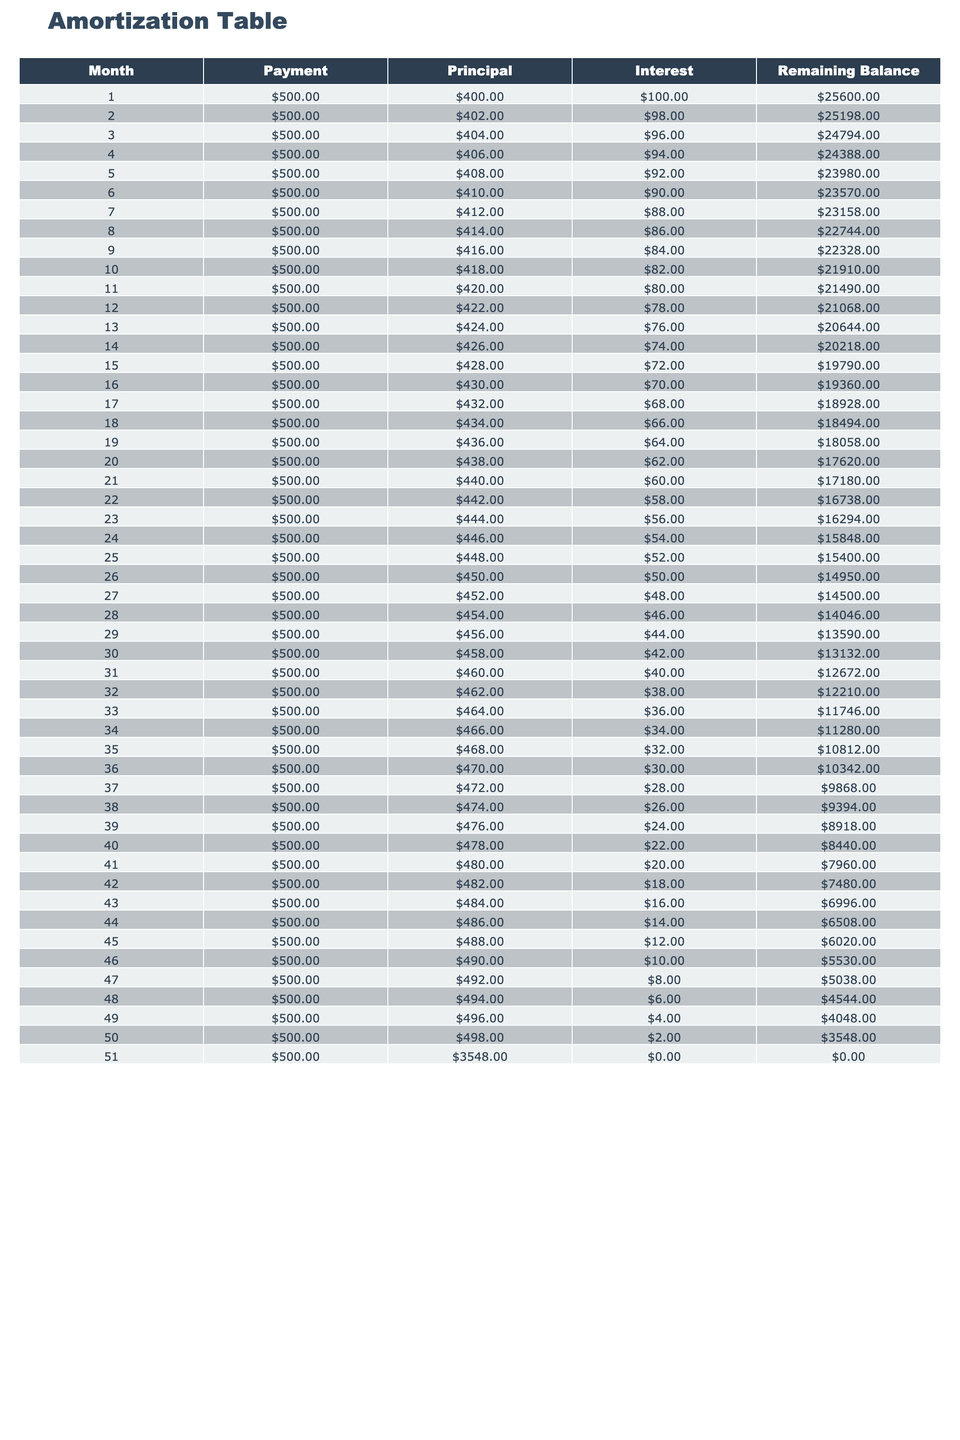What is the payment for the first month? The payment amount in the first row of the table under the "Payment" column shows 500.00.
Answer: 500.00 What is the remaining balance after the second month? In the second row of the table, the "Remaining Balance" column states 25198.00. Thus, after the second month, the remaining balance is 25198.00.
Answer: 25198.00 How much total principal is paid off in the first 5 months? The principal amounts in the first 5 months are 400.00, 402.00, 404.00, 406.00, and 408.00 respectively. Summing these values: 400 + 402 + 404 + 406 + 408 = 2020.00.
Answer: 2020.00 Is the interest payment in the last month equal to zero? In the last row for the 51st month, the "Interest" amount is 0.00, which confirms that the interest paid in this month is indeed zero.
Answer: Yes What is the average amount of interest paid over the first 12 months? The interest payments for the first 12 months are 100.00, 98.00, 96.00, 94.00, 92.00, 90.00, 88.00, 86.00, 84.00, 82.00, 80.00, and 78.00. Summing these values: 100 + 98 + 96 + 94 + 92 + 90 + 88 + 86 + 84 + 82 + 80 + 78 = 1092.00. There are 12 months, so the average is 1092.00 / 12 = 91.00.
Answer: 91.00 What is the trend in the principal amount paid each month? The principal payment increases each month, ranging from 400.00 in the first month and reaching 494.00 in the last month. The consistent increase indicates that more principal is being paid off, which is typical in amortization schedules.
Answer: Increasing How much total interest is paid by the end of the loan period? To find the total interest, we would sum all interest payments from month 1 to month 51. By inserting all values from the "Interest" column, we can calculate the total interest. This is (100 + 98 + 96 + ... + 2 + 0 = 1550.00). Thus, the total interest paid over the entire loan period is 1550.00.
Answer: 1550.00 What is the remaining balance after 36 months? Referring to the table, the "Remaining Balance" after 36 months is listed as 10342.00 in the 36th row. Therefore, the remaining balance after three years of payments is 10342.00.
Answer: 10342.00 